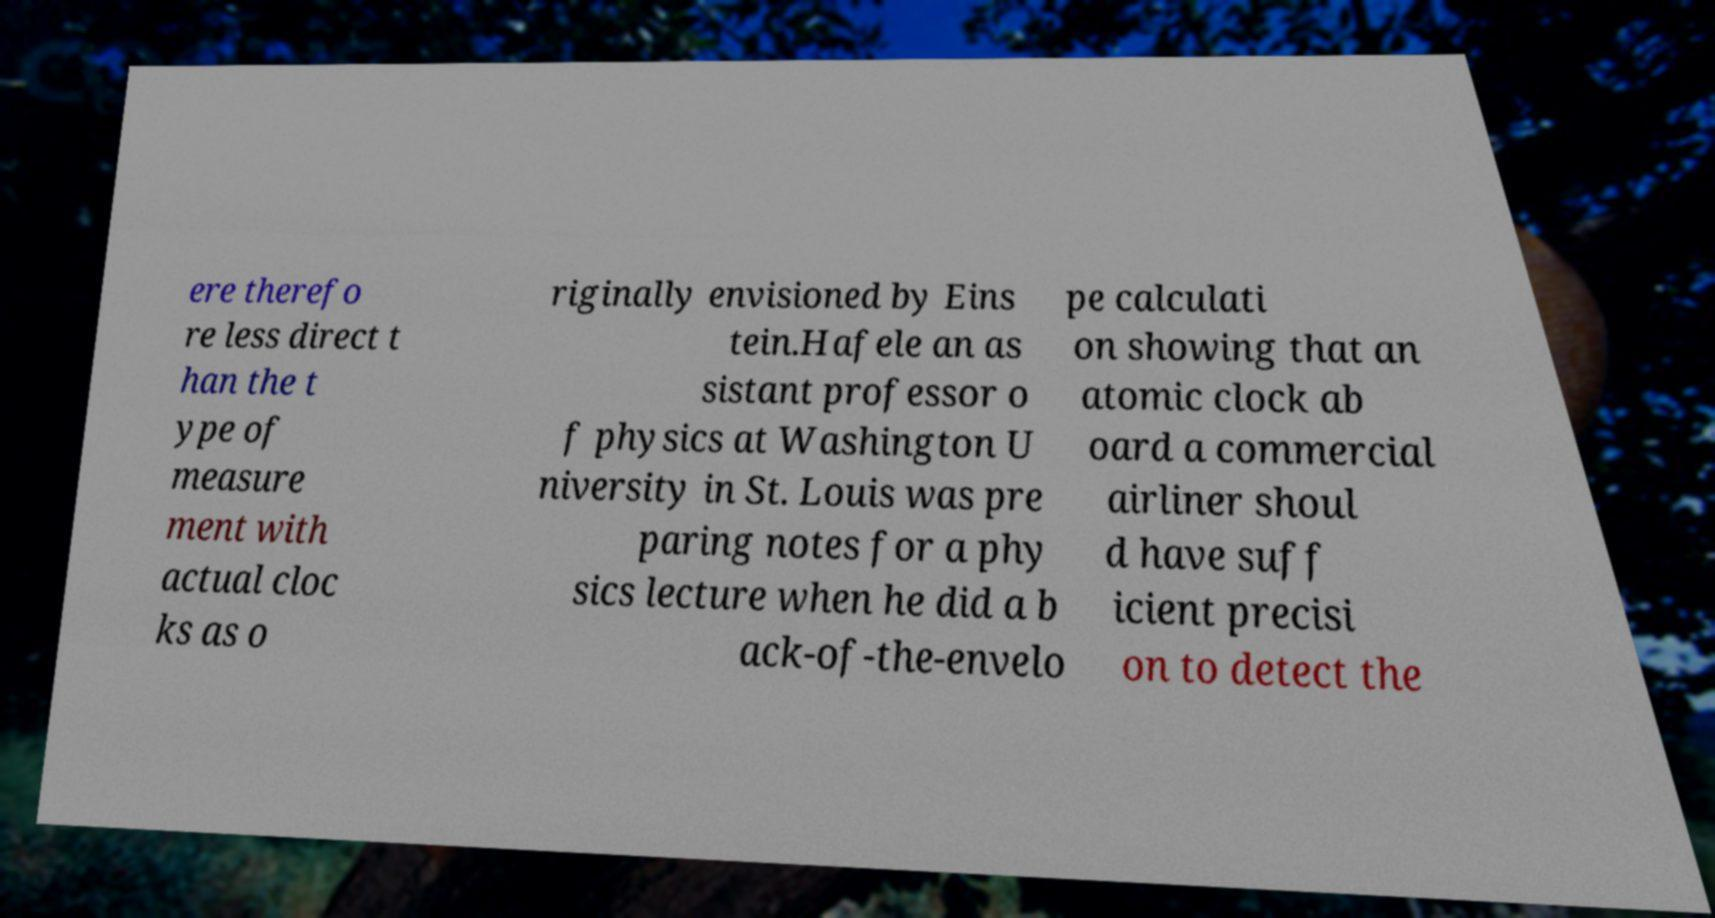Can you accurately transcribe the text from the provided image for me? ere therefo re less direct t han the t ype of measure ment with actual cloc ks as o riginally envisioned by Eins tein.Hafele an as sistant professor o f physics at Washington U niversity in St. Louis was pre paring notes for a phy sics lecture when he did a b ack-of-the-envelo pe calculati on showing that an atomic clock ab oard a commercial airliner shoul d have suff icient precisi on to detect the 